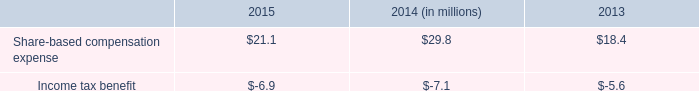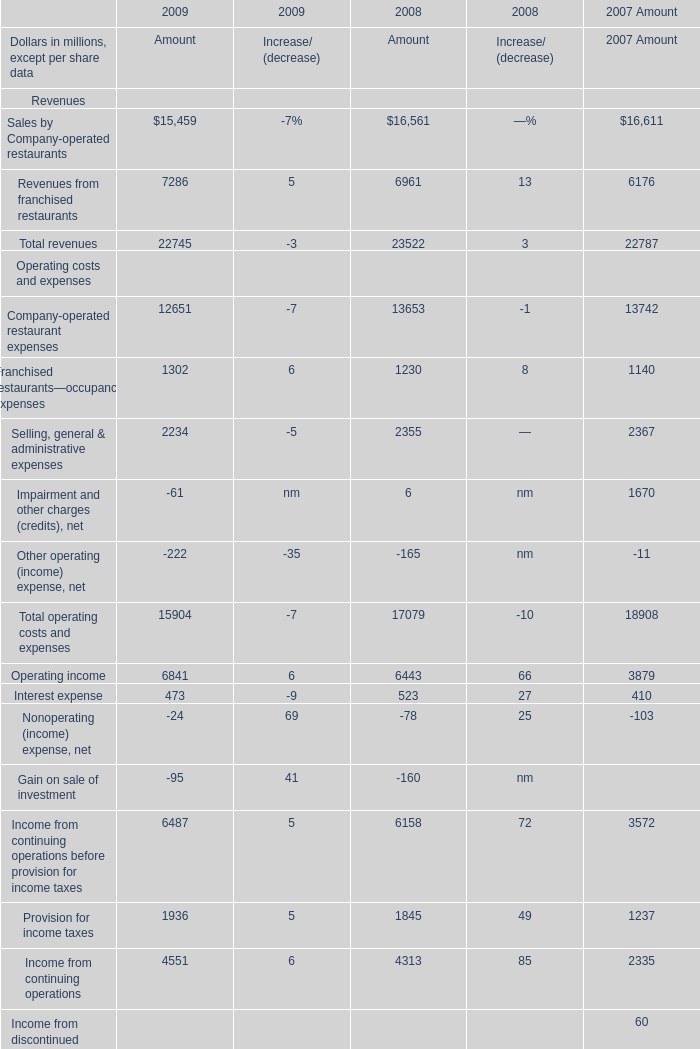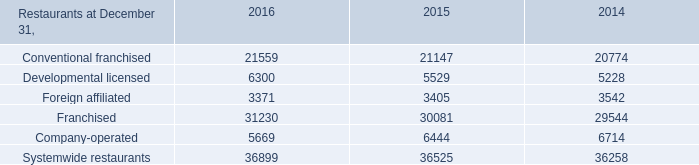Does the value of Sales by Company-operated restaurants in 2009 greater than that in2008? 
Answer: no. 